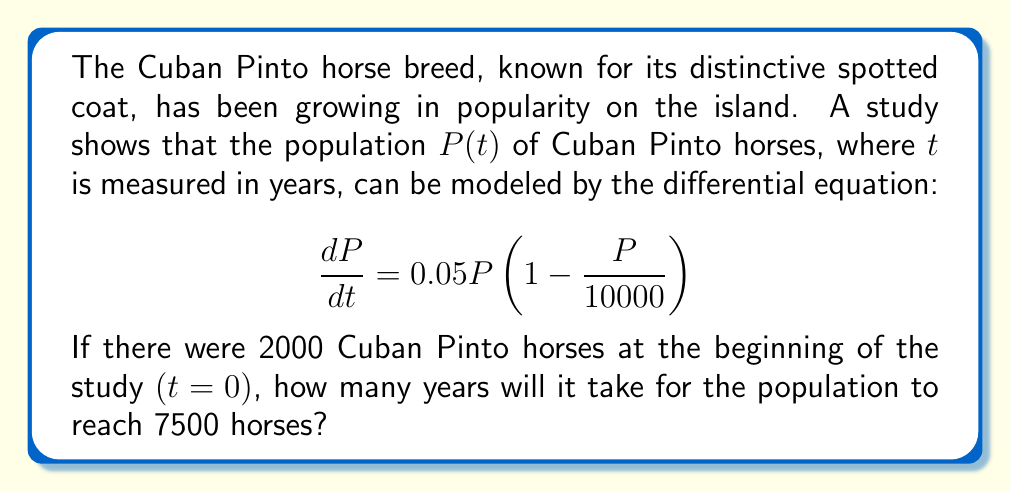Solve this math problem. To solve this problem, we need to use the logistic growth model and separate variables to integrate:

1) The given equation is a logistic growth model with a carrying capacity of 10000 horses and a growth rate of 0.05.

2) Separate variables and integrate:
   $$\int_{2000}^{7500} \frac{dP}{P(1-\frac{P}{10000})} = \int_0^t 0.05 dt$$

3) The left side can be integrated using partial fractions:
   $$\left[-\ln|10000-P| - \ln|P|\right]_{2000}^{7500} = 0.05t$$

4) Evaluate the left side:
   $$\left[-\ln|2500| - \ln|7500|\right] - \left[-\ln|8000| - \ln|2000|\right] = 0.05t$$

5) Simplify:
   $$\ln\left(\frac{8000 \cdot 7500}{2500 \cdot 2000}\right) = 0.05t$$

6) Solve for $t$:
   $$t = \frac{1}{0.05} \ln\left(\frac{8000 \cdot 7500}{2500 \cdot 2000}\right) \approx 39.96$$

Therefore, it will take approximately 40 years for the Cuban Pinto horse population to reach 7500 from an initial population of 2000.
Answer: Approximately 40 years 